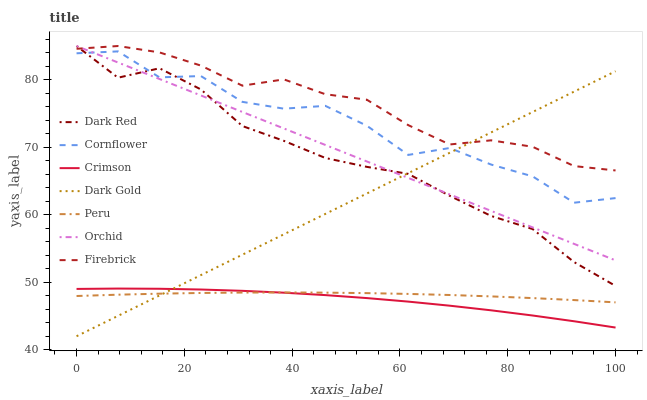Does Crimson have the minimum area under the curve?
Answer yes or no. Yes. Does Firebrick have the maximum area under the curve?
Answer yes or no. Yes. Does Dark Gold have the minimum area under the curve?
Answer yes or no. No. Does Dark Gold have the maximum area under the curve?
Answer yes or no. No. Is Dark Gold the smoothest?
Answer yes or no. Yes. Is Cornflower the roughest?
Answer yes or no. Yes. Is Dark Red the smoothest?
Answer yes or no. No. Is Dark Red the roughest?
Answer yes or no. No. Does Dark Red have the lowest value?
Answer yes or no. No. Does Orchid have the highest value?
Answer yes or no. Yes. Does Dark Gold have the highest value?
Answer yes or no. No. Is Peru less than Dark Red?
Answer yes or no. Yes. Is Cornflower greater than Crimson?
Answer yes or no. Yes. Does Crimson intersect Peru?
Answer yes or no. Yes. Is Crimson less than Peru?
Answer yes or no. No. Is Crimson greater than Peru?
Answer yes or no. No. Does Peru intersect Dark Red?
Answer yes or no. No. 